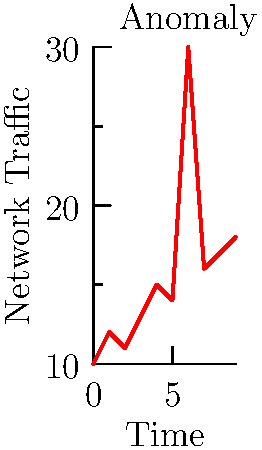In the network traffic visualization for an intrusion detection system shown above, at which time point does an anomaly occur that could indicate a potential security breach? To identify the anomaly in this network traffic visualization:

1. Observe the general trend: The graph shows a relatively steady increase in network traffic over time.

2. Look for outliers: There is a significant spike in traffic at time point 6.

3. Compare the spike to surrounding data points:
   - At time 5, the traffic is around 14 units
   - At time 6, it suddenly jumps to 30 units
   - At time 7, it drops back down to about 16 units

4. Assess the magnitude of the spike: The jump to 30 units is approximately double the expected value based on the trend.

5. Consider potential causes: Such a sudden, large increase in network traffic could indicate:
   - A Distributed Denial of Service (DDoS) attack
   - Data exfiltration
   - Malware spreading across the network

6. Conclude: The anomaly occurs at time point 6, which warrants further investigation as a potential security breach.
Answer: 6 